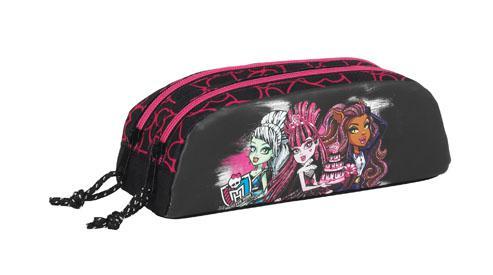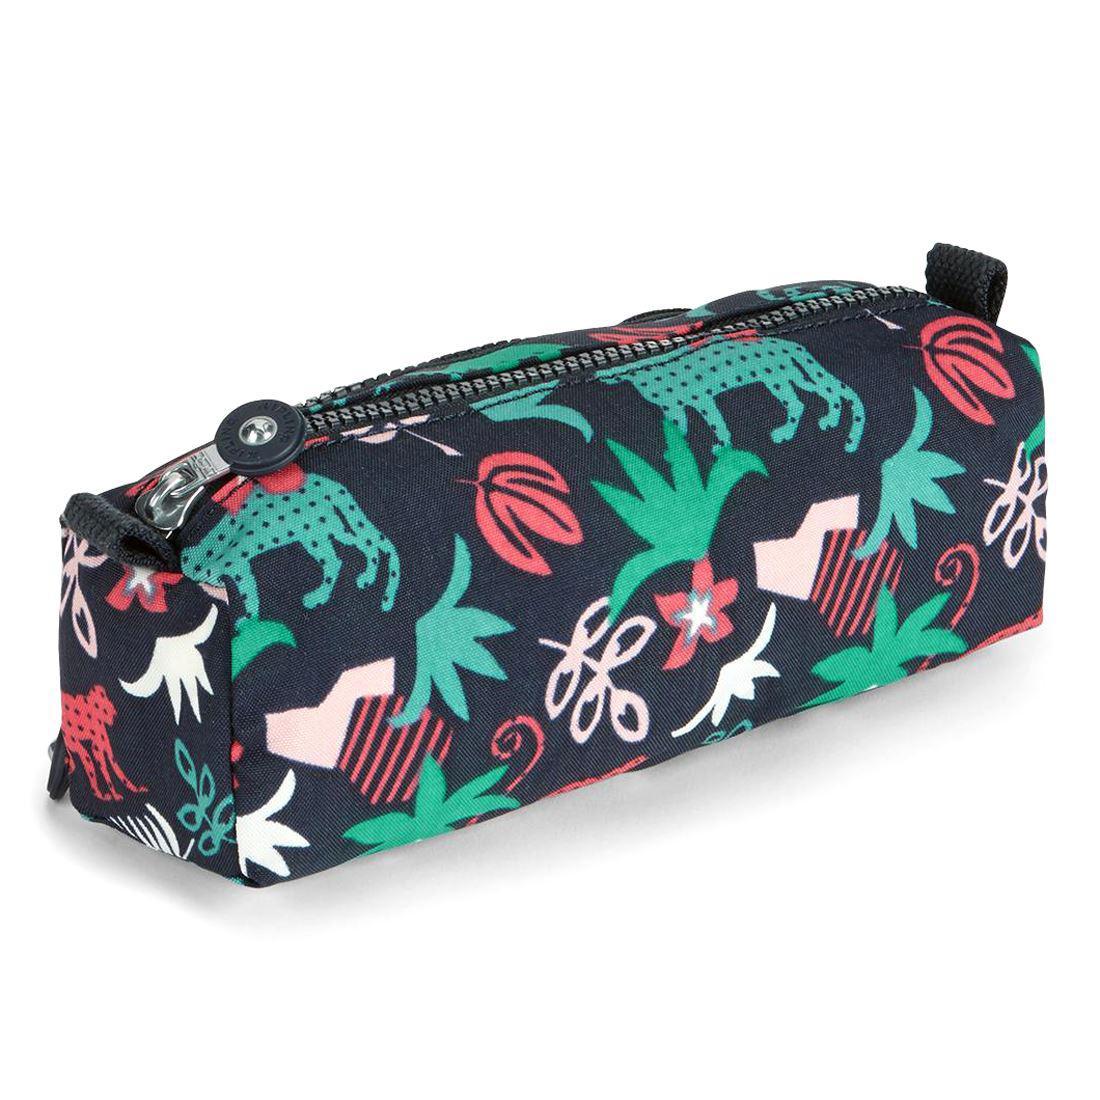The first image is the image on the left, the second image is the image on the right. Considering the images on both sides, is "There is a Monster High pencil case." valid? Answer yes or no. Yes. The first image is the image on the left, the second image is the image on the right. Evaluate the accuracy of this statement regarding the images: "in the image pair there are two oval shaped pencil pouches with cording on the outside". Is it true? Answer yes or no. No. 